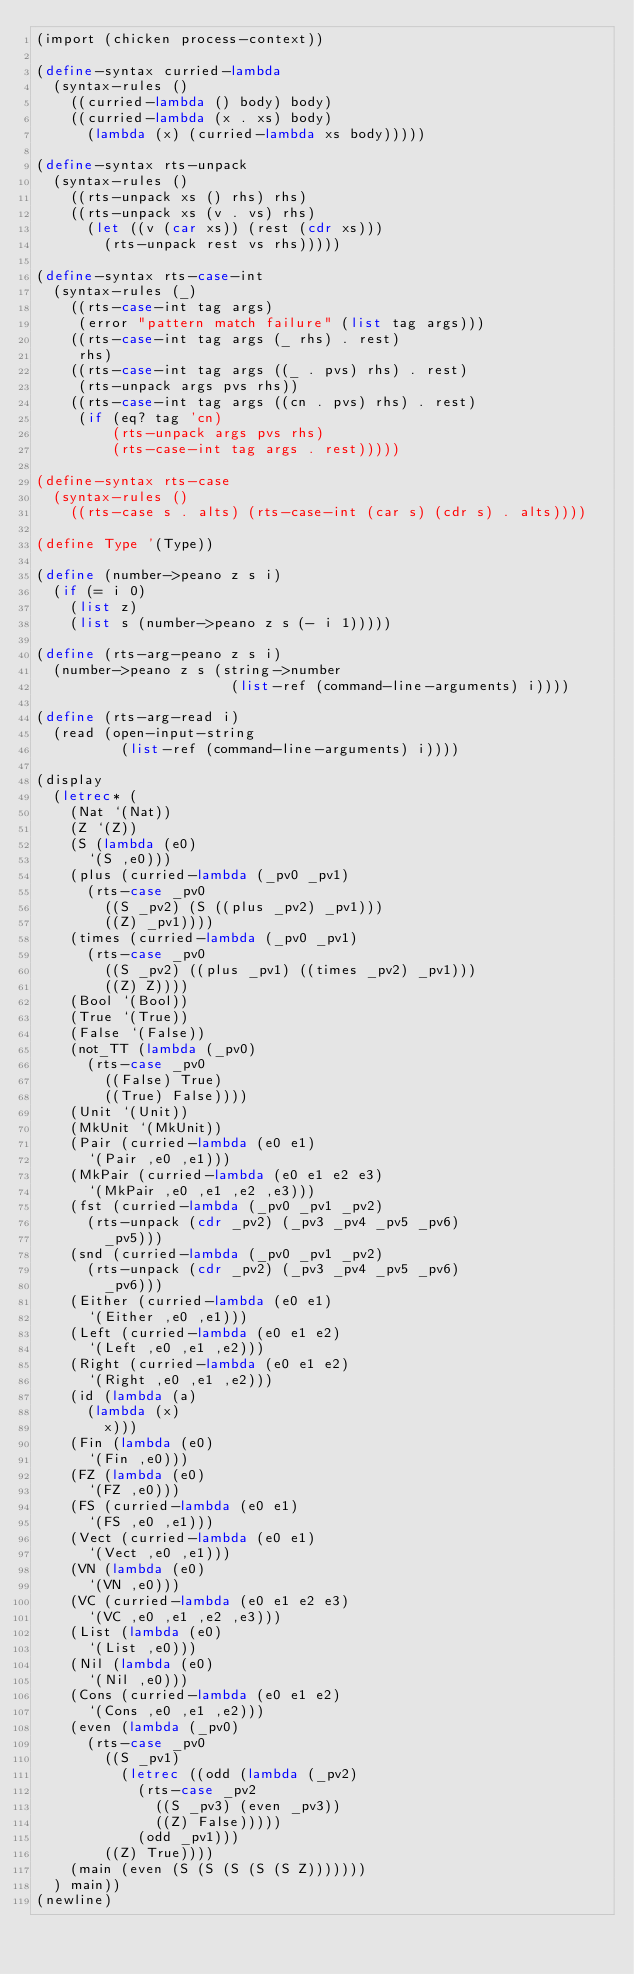<code> <loc_0><loc_0><loc_500><loc_500><_Scheme_>(import (chicken process-context))

(define-syntax curried-lambda
  (syntax-rules ()
    ((curried-lambda () body) body)
    ((curried-lambda (x . xs) body)
      (lambda (x) (curried-lambda xs body)))))

(define-syntax rts-unpack
  (syntax-rules ()
    ((rts-unpack xs () rhs) rhs)
    ((rts-unpack xs (v . vs) rhs)
      (let ((v (car xs)) (rest (cdr xs)))
        (rts-unpack rest vs rhs)))))

(define-syntax rts-case-int
  (syntax-rules (_)
    ((rts-case-int tag args)
     (error "pattern match failure" (list tag args)))
    ((rts-case-int tag args (_ rhs) . rest)
     rhs)
    ((rts-case-int tag args ((_ . pvs) rhs) . rest)
     (rts-unpack args pvs rhs))
    ((rts-case-int tag args ((cn . pvs) rhs) . rest)
     (if (eq? tag 'cn)
         (rts-unpack args pvs rhs)
         (rts-case-int tag args . rest)))))

(define-syntax rts-case
  (syntax-rules ()
    ((rts-case s . alts) (rts-case-int (car s) (cdr s) . alts))))

(define Type '(Type))

(define (number->peano z s i)
  (if (= i 0)
    (list z)
    (list s (number->peano z s (- i 1)))))

(define (rts-arg-peano z s i)
  (number->peano z s (string->number
                       (list-ref (command-line-arguments) i))))

(define (rts-arg-read i)
  (read (open-input-string
          (list-ref (command-line-arguments) i))))

(display 
  (letrec* (
    (Nat `(Nat))
    (Z `(Z))
    (S (lambda (e0)
      `(S ,e0)))
    (plus (curried-lambda (_pv0 _pv1)
      (rts-case _pv0
        ((S _pv2) (S ((plus _pv2) _pv1)))
        ((Z) _pv1))))
    (times (curried-lambda (_pv0 _pv1)
      (rts-case _pv0
        ((S _pv2) ((plus _pv1) ((times _pv2) _pv1)))
        ((Z) Z))))
    (Bool `(Bool))
    (True `(True))
    (False `(False))
    (not_TT (lambda (_pv0)
      (rts-case _pv0
        ((False) True)
        ((True) False))))
    (Unit `(Unit))
    (MkUnit `(MkUnit))
    (Pair (curried-lambda (e0 e1)
      `(Pair ,e0 ,e1)))
    (MkPair (curried-lambda (e0 e1 e2 e3)
      `(MkPair ,e0 ,e1 ,e2 ,e3)))
    (fst (curried-lambda (_pv0 _pv1 _pv2)
      (rts-unpack (cdr _pv2) (_pv3 _pv4 _pv5 _pv6)
        _pv5)))
    (snd (curried-lambda (_pv0 _pv1 _pv2)
      (rts-unpack (cdr _pv2) (_pv3 _pv4 _pv5 _pv6)
        _pv6)))
    (Either (curried-lambda (e0 e1)
      `(Either ,e0 ,e1)))
    (Left (curried-lambda (e0 e1 e2)
      `(Left ,e0 ,e1 ,e2)))
    (Right (curried-lambda (e0 e1 e2)
      `(Right ,e0 ,e1 ,e2)))
    (id (lambda (a)
      (lambda (x)
        x)))
    (Fin (lambda (e0)
      `(Fin ,e0)))
    (FZ (lambda (e0)
      `(FZ ,e0)))
    (FS (curried-lambda (e0 e1)
      `(FS ,e0 ,e1)))
    (Vect (curried-lambda (e0 e1)
      `(Vect ,e0 ,e1)))
    (VN (lambda (e0)
      `(VN ,e0)))
    (VC (curried-lambda (e0 e1 e2 e3)
      `(VC ,e0 ,e1 ,e2 ,e3)))
    (List (lambda (e0)
      `(List ,e0)))
    (Nil (lambda (e0)
      `(Nil ,e0)))
    (Cons (curried-lambda (e0 e1 e2)
      `(Cons ,e0 ,e1 ,e2)))
    (even (lambda (_pv0)
      (rts-case _pv0
        ((S _pv1) 
          (letrec ((odd (lambda (_pv2)
            (rts-case _pv2
              ((S _pv3) (even _pv3))
              ((Z) False)))))
            (odd _pv1)))
        ((Z) True))))
    (main (even (S (S (S (S (S Z)))))))
  ) main))
(newline)
</code> 